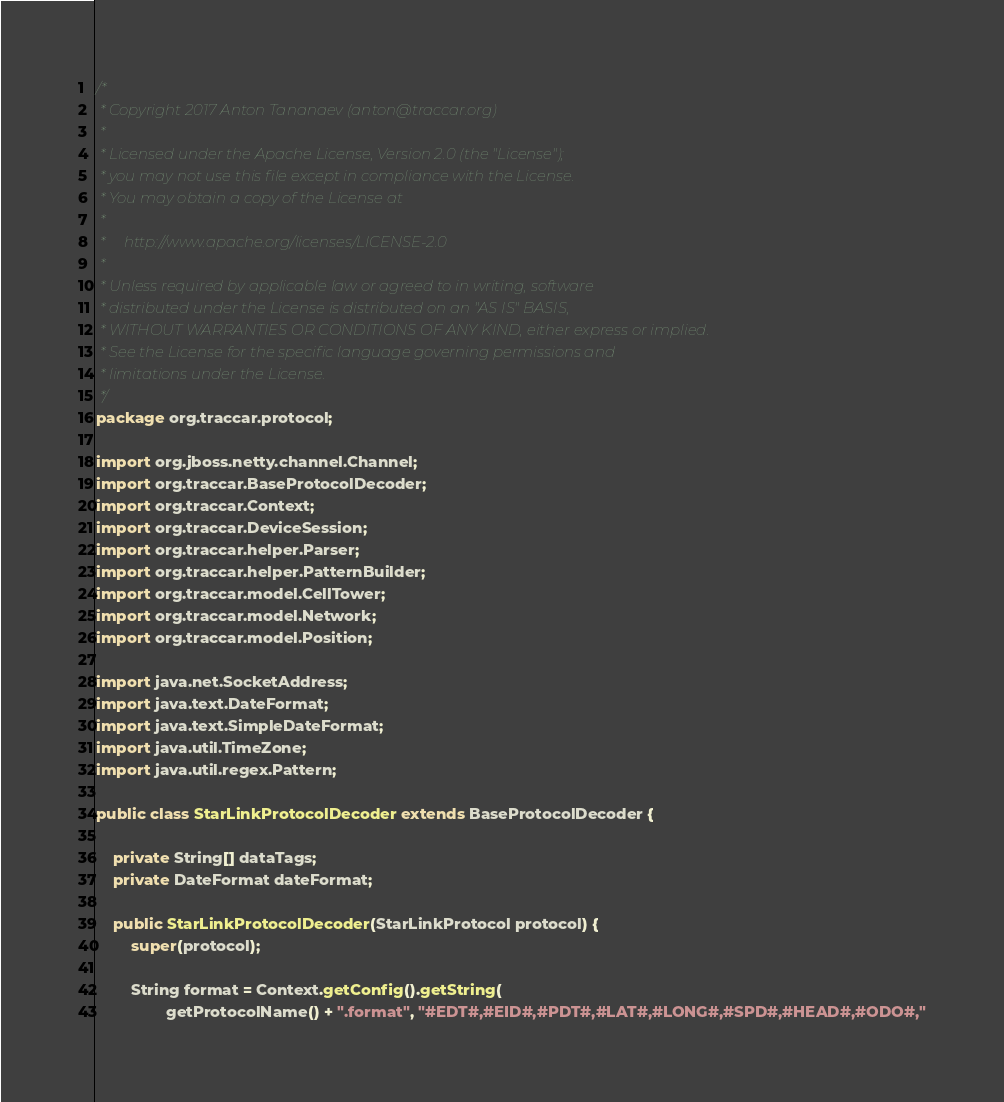<code> <loc_0><loc_0><loc_500><loc_500><_Java_>/*
 * Copyright 2017 Anton Tananaev (anton@traccar.org)
 *
 * Licensed under the Apache License, Version 2.0 (the "License");
 * you may not use this file except in compliance with the License.
 * You may obtain a copy of the License at
 *
 *     http://www.apache.org/licenses/LICENSE-2.0
 *
 * Unless required by applicable law or agreed to in writing, software
 * distributed under the License is distributed on an "AS IS" BASIS,
 * WITHOUT WARRANTIES OR CONDITIONS OF ANY KIND, either express or implied.
 * See the License for the specific language governing permissions and
 * limitations under the License.
 */
package org.traccar.protocol;

import org.jboss.netty.channel.Channel;
import org.traccar.BaseProtocolDecoder;
import org.traccar.Context;
import org.traccar.DeviceSession;
import org.traccar.helper.Parser;
import org.traccar.helper.PatternBuilder;
import org.traccar.model.CellTower;
import org.traccar.model.Network;
import org.traccar.model.Position;

import java.net.SocketAddress;
import java.text.DateFormat;
import java.text.SimpleDateFormat;
import java.util.TimeZone;
import java.util.regex.Pattern;

public class StarLinkProtocolDecoder extends BaseProtocolDecoder {

    private String[] dataTags;
    private DateFormat dateFormat;

    public StarLinkProtocolDecoder(StarLinkProtocol protocol) {
        super(protocol);

        String format = Context.getConfig().getString(
                getProtocolName() + ".format", "#EDT#,#EID#,#PDT#,#LAT#,#LONG#,#SPD#,#HEAD#,#ODO#,"</code> 